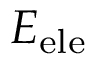<formula> <loc_0><loc_0><loc_500><loc_500>E _ { e l e }</formula> 